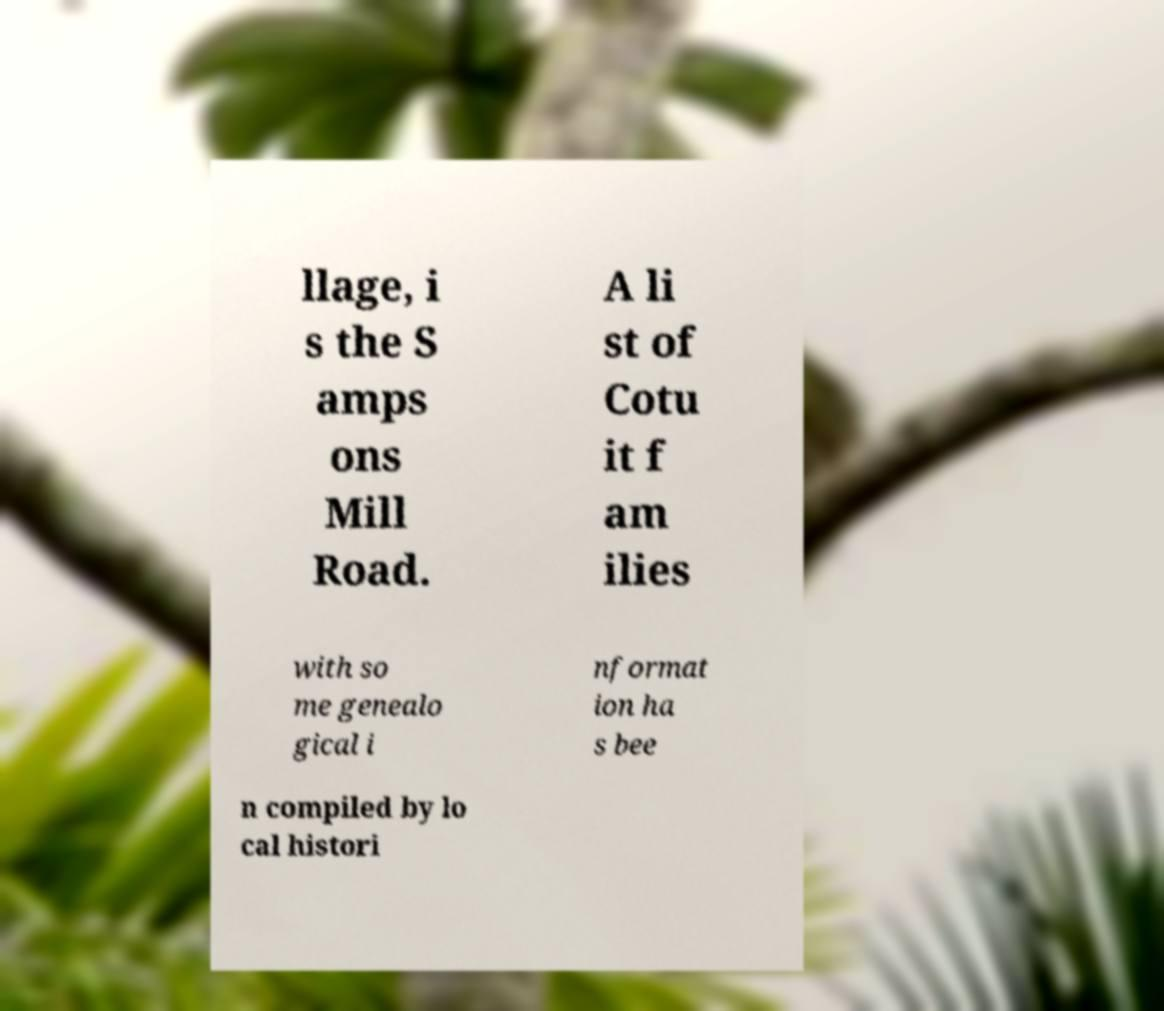There's text embedded in this image that I need extracted. Can you transcribe it verbatim? llage, i s the S amps ons Mill Road. A li st of Cotu it f am ilies with so me genealo gical i nformat ion ha s bee n compiled by lo cal histori 